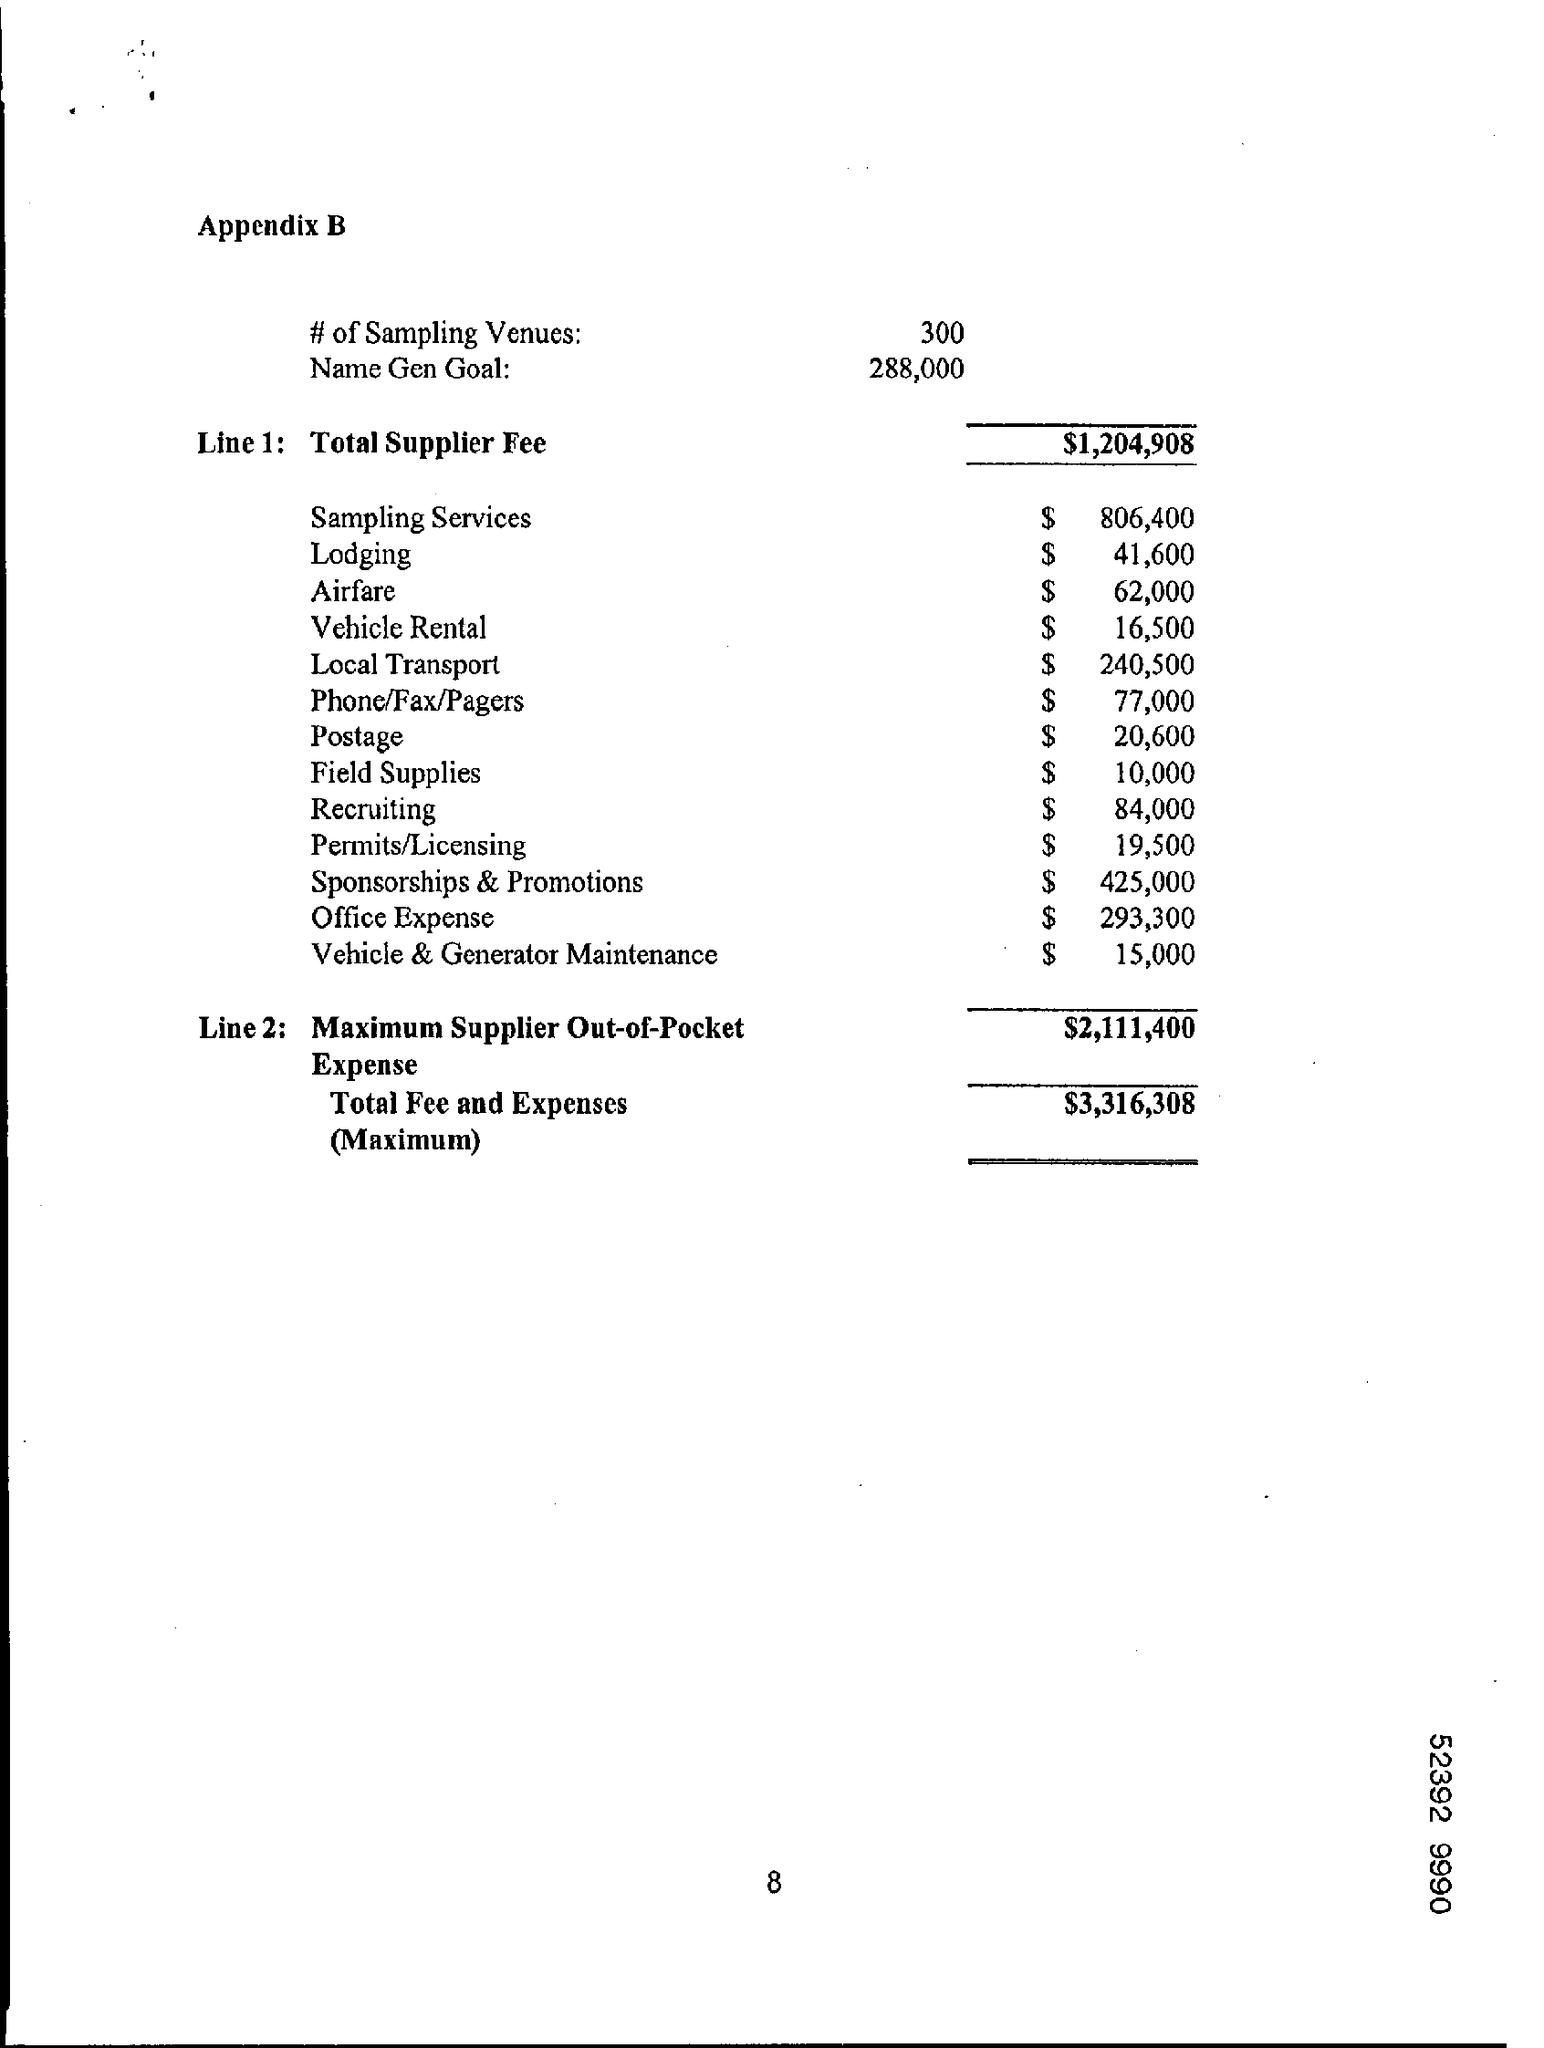Which appendix is mentioned in the document
Keep it short and to the point. Appendix B. How many number of sampling venues are mentioned in the document?
Offer a very short reply. 300. What is the maximum total fees and expenses?
Your response must be concise. $3,316,308. What is the total supplier fees?
Keep it short and to the point. $1,204,908. 